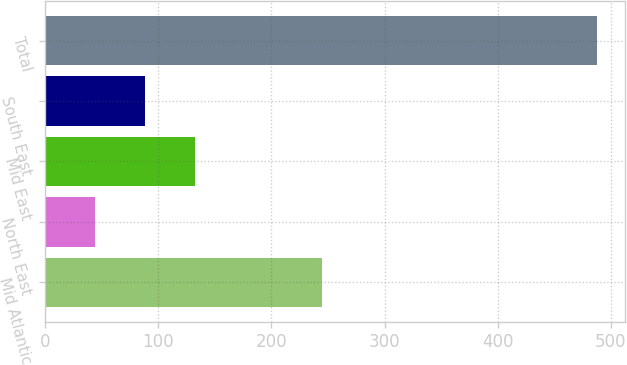<chart> <loc_0><loc_0><loc_500><loc_500><bar_chart><fcel>Mid Atlantic<fcel>North East<fcel>Mid East<fcel>South East<fcel>Total<nl><fcel>245<fcel>44<fcel>132.8<fcel>88.4<fcel>488<nl></chart> 